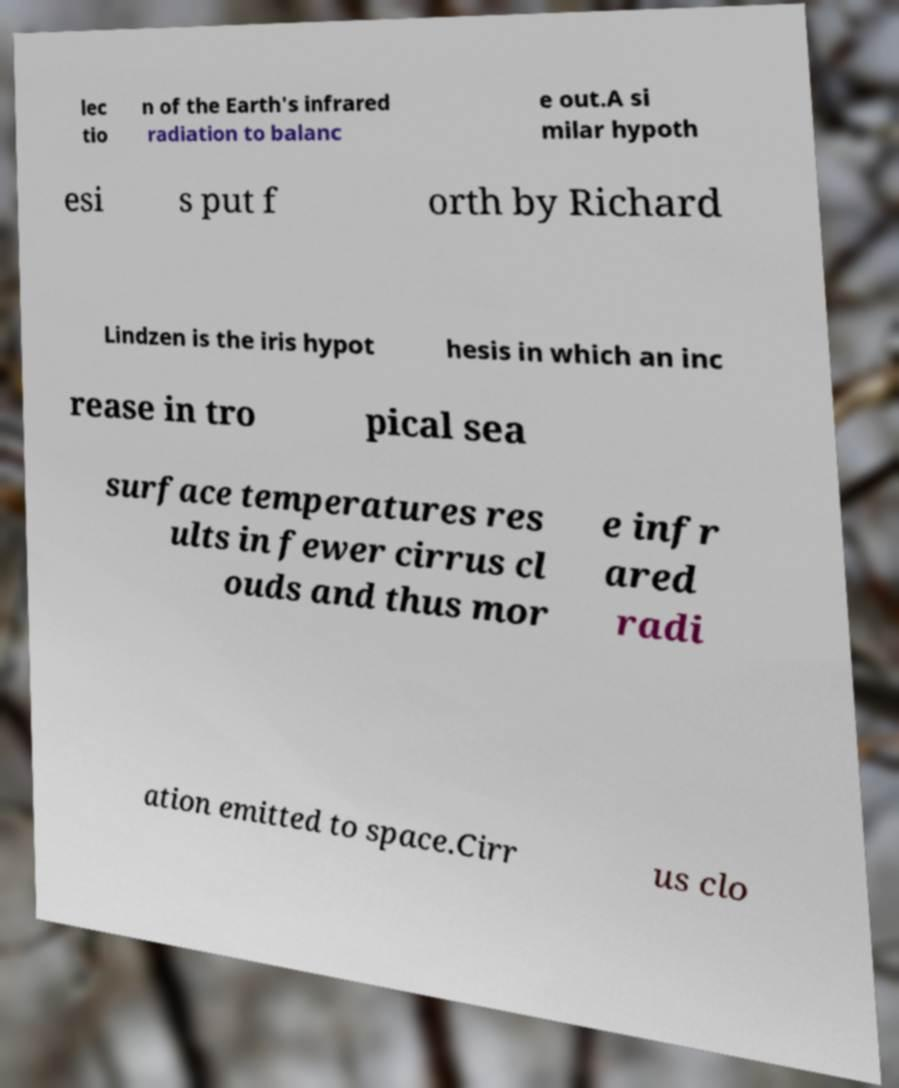Please read and relay the text visible in this image. What does it say? lec tio n of the Earth's infrared radiation to balanc e out.A si milar hypoth esi s put f orth by Richard Lindzen is the iris hypot hesis in which an inc rease in tro pical sea surface temperatures res ults in fewer cirrus cl ouds and thus mor e infr ared radi ation emitted to space.Cirr us clo 